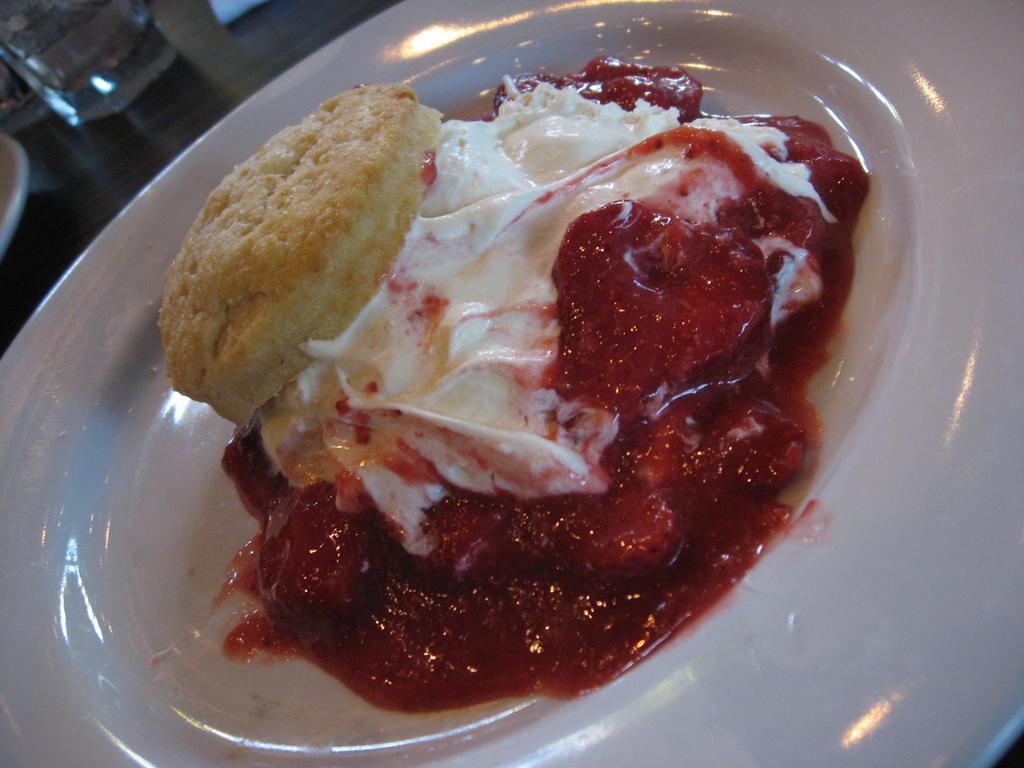Can you describe this image briefly? This is a table. I can see a plate, glass and few other objects on the table. This plate contains a food item in it. 